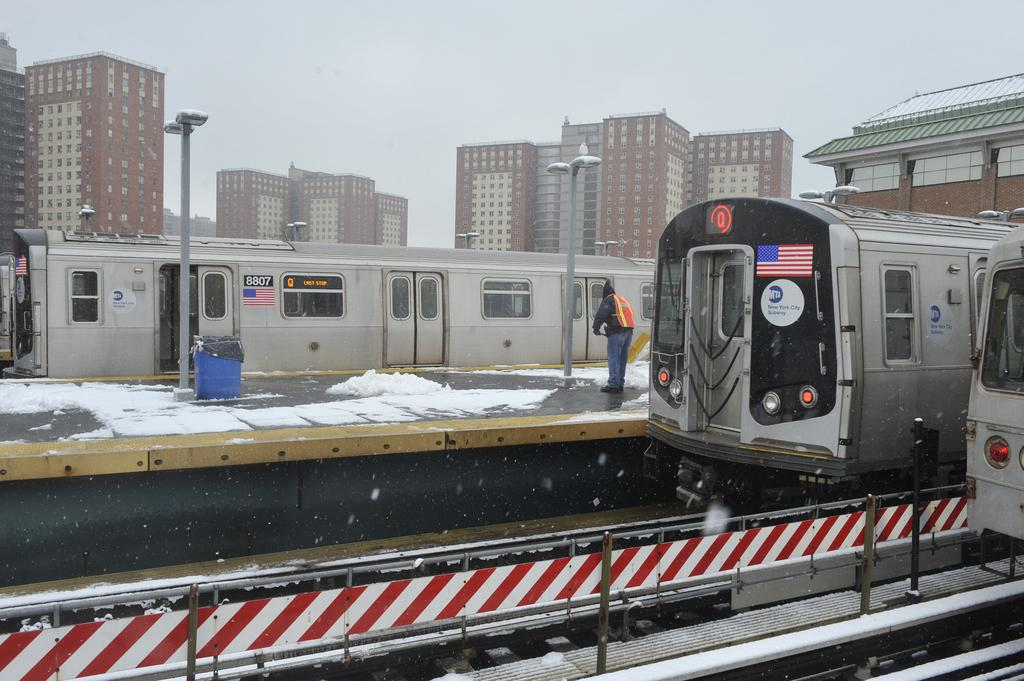What type of location is depicted in the image? The image depicts a city. What weather condition can be observed in the image? There is snowfall in the image. What mode of transportation is present in the image? There are trains on the railway tracks. Can you describe the person in the image? A person is standing on the platform. What structures are present in the image? There are poles, lights, dustbins, and buildings in the image. What is visible in the sky in the image? The sky is visible in the image. What type of account is the person in the image trying to open? There is no indication in the image that the person is trying to open an account. What type of acoustics can be heard in the image? There is no sound present in the image, so it's not possible to determine the acoustics. What type of quiver is the person holding in the image? There is no person holding a quiver in the image. 